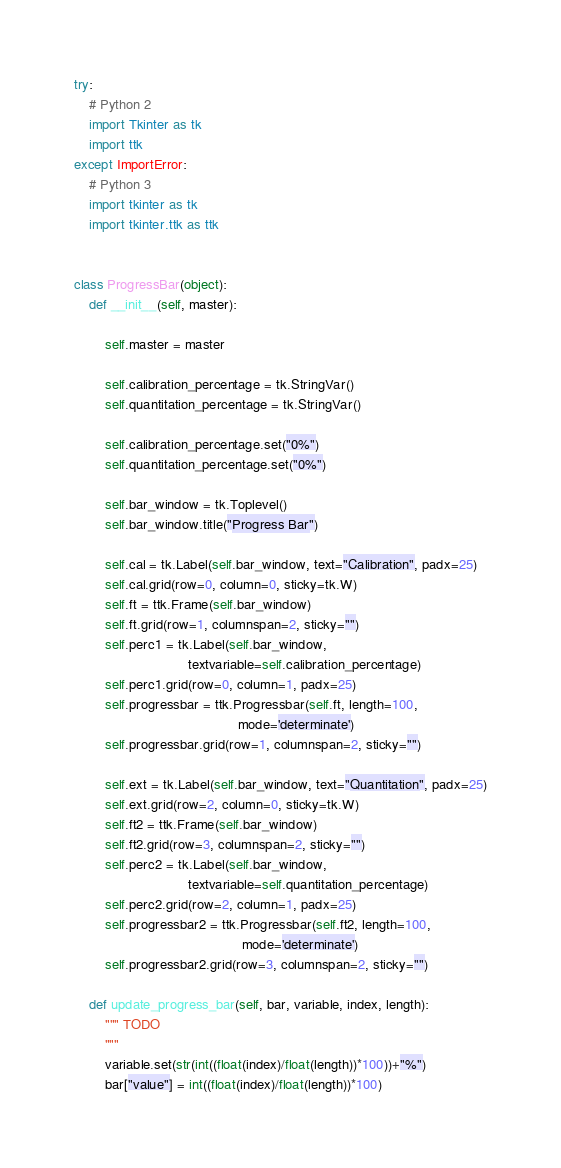<code> <loc_0><loc_0><loc_500><loc_500><_Python_>try:
    # Python 2
    import Tkinter as tk
    import ttk
except ImportError:
    # Python 3
    import tkinter as tk
    import tkinter.ttk as ttk


class ProgressBar(object):
    def __init__(self, master):

        self.master = master

        self.calibration_percentage = tk.StringVar()
        self.quantitation_percentage = tk.StringVar()

        self.calibration_percentage.set("0%")
        self.quantitation_percentage.set("0%")

        self.bar_window = tk.Toplevel()
        self.bar_window.title("Progress Bar")

        self.cal = tk.Label(self.bar_window, text="Calibration", padx=25)
        self.cal.grid(row=0, column=0, sticky=tk.W)
        self.ft = ttk.Frame(self.bar_window)
        self.ft.grid(row=1, columnspan=2, sticky="")
        self.perc1 = tk.Label(self.bar_window,
                              textvariable=self.calibration_percentage)
        self.perc1.grid(row=0, column=1, padx=25)
        self.progressbar = ttk.Progressbar(self.ft, length=100,
                                           mode='determinate')
        self.progressbar.grid(row=1, columnspan=2, sticky="")

        self.ext = tk.Label(self.bar_window, text="Quantitation", padx=25)
        self.ext.grid(row=2, column=0, sticky=tk.W)
        self.ft2 = ttk.Frame(self.bar_window)
        self.ft2.grid(row=3, columnspan=2, sticky="")
        self.perc2 = tk.Label(self.bar_window,
                              textvariable=self.quantitation_percentage)
        self.perc2.grid(row=2, column=1, padx=25)
        self.progressbar2 = ttk.Progressbar(self.ft2, length=100,
                                            mode='determinate')
        self.progressbar2.grid(row=3, columnspan=2, sticky="")

    def update_progress_bar(self, bar, variable, index, length):
        """ TODO
        """
        variable.set(str(int((float(index)/float(length))*100))+"%")
        bar["value"] = int((float(index)/float(length))*100)</code> 